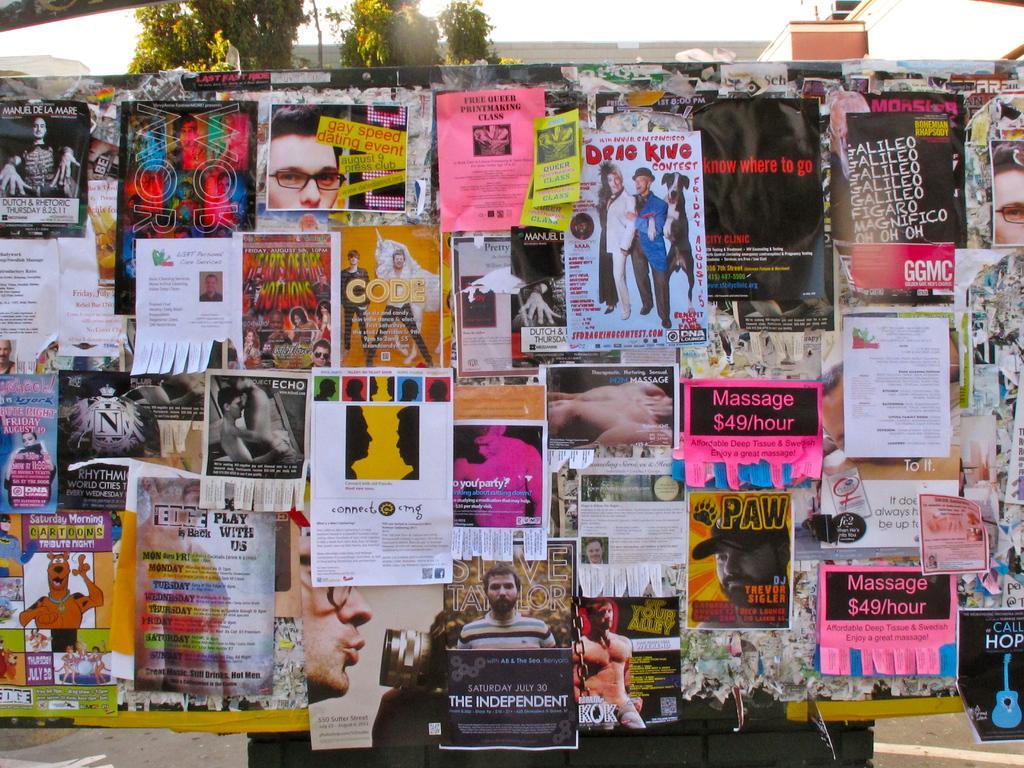Can you describe this image briefly? In this image there is a board and we can see posters pasted on the board. In the background there are trees and sky. We can see buildings. 